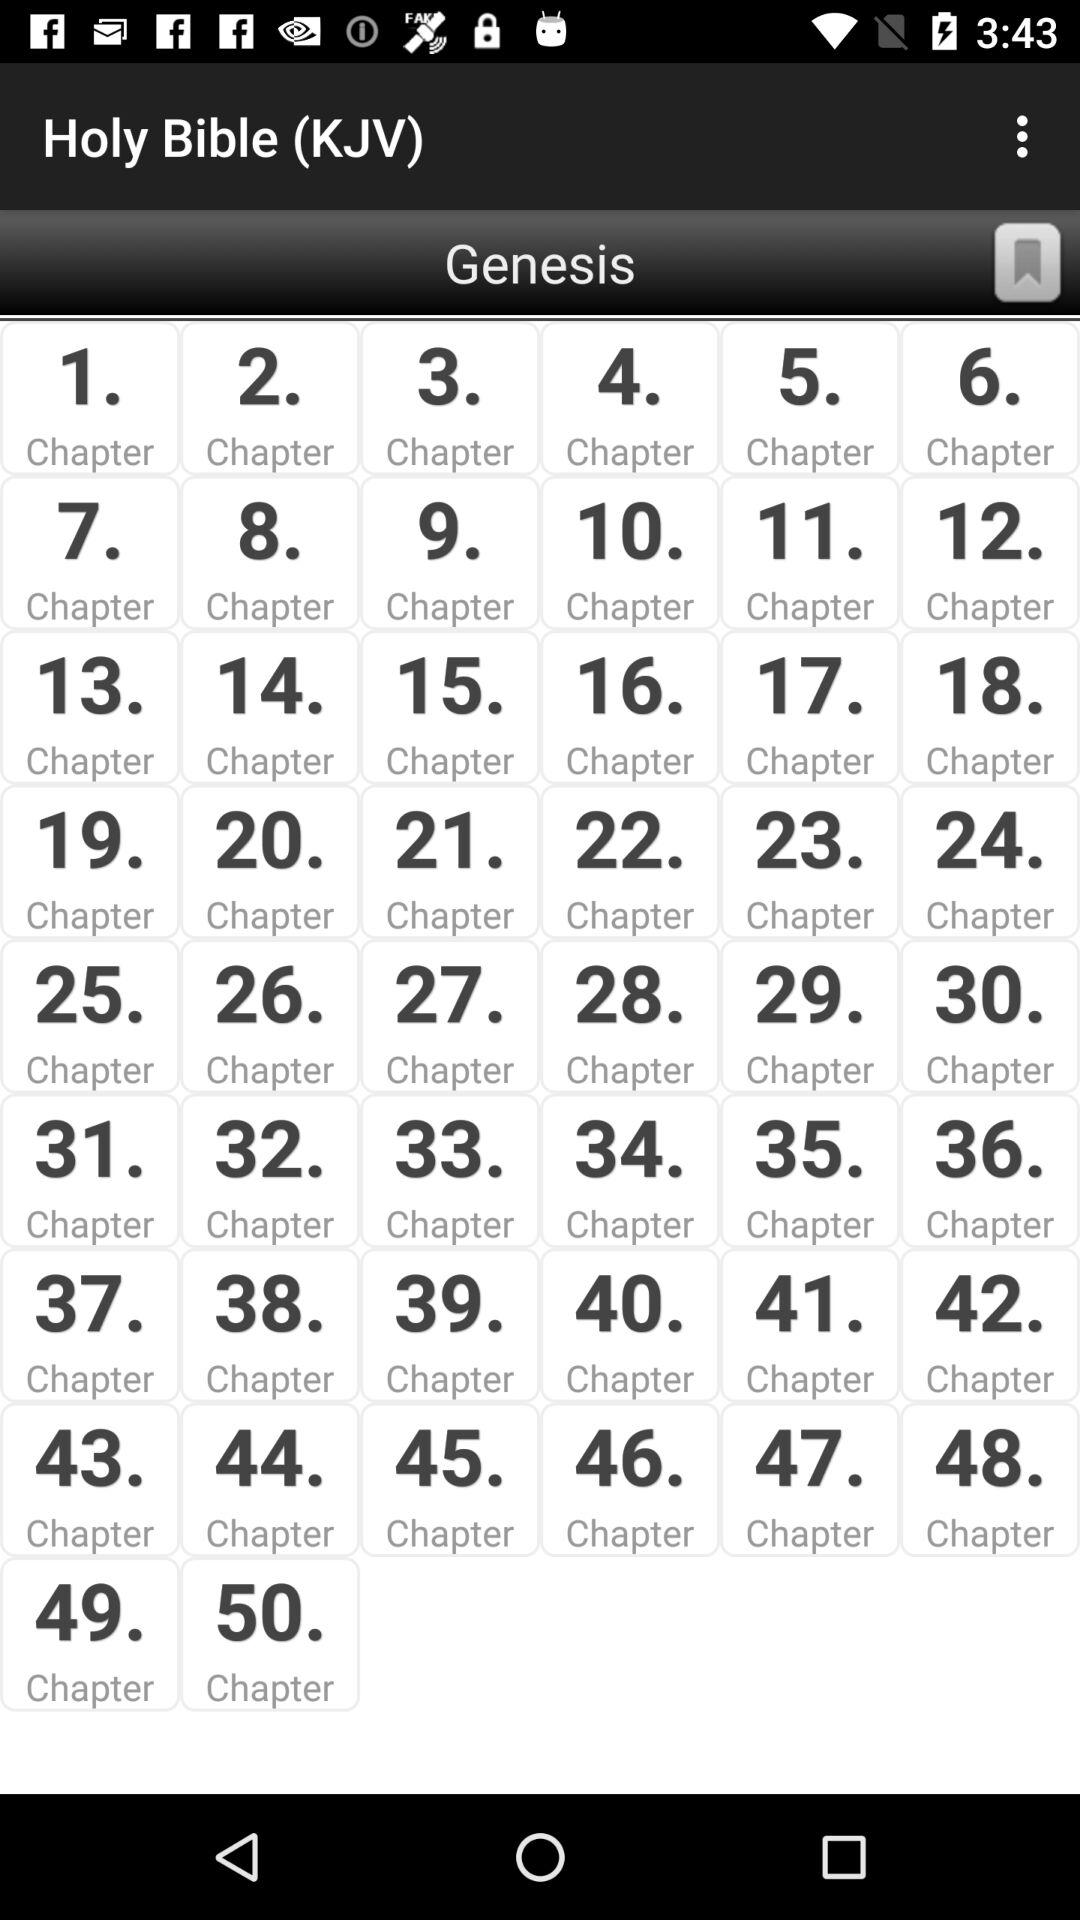How many chapters are in Genesis?
Answer the question using a single word or phrase. 50 